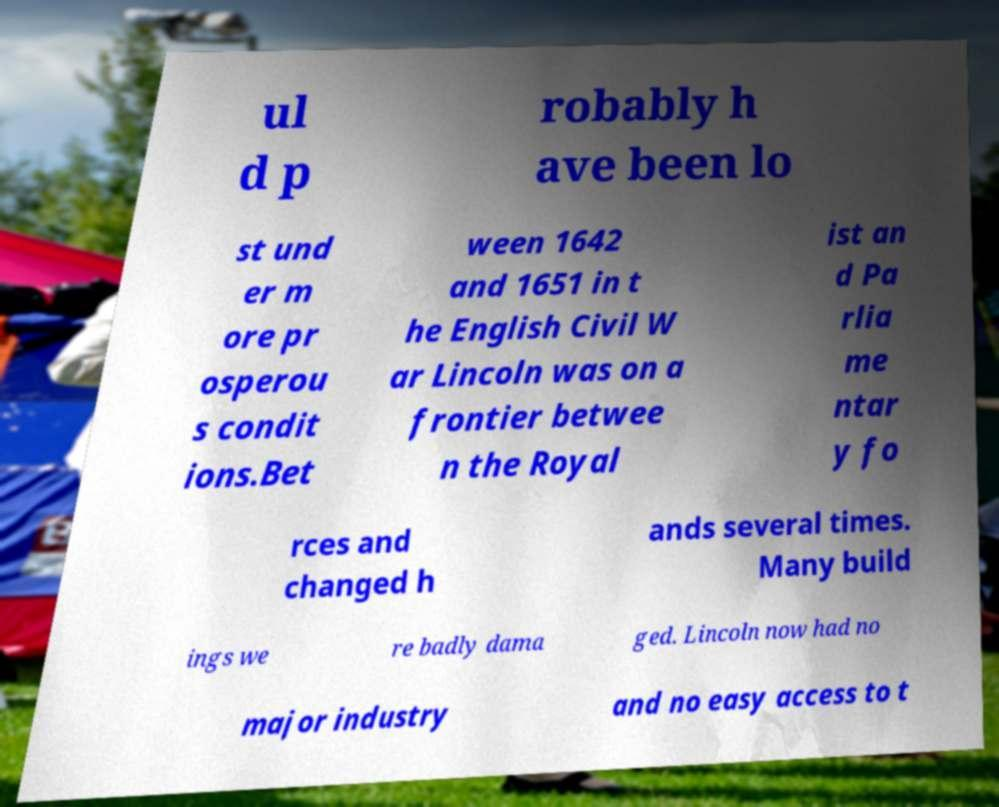Can you read and provide the text displayed in the image?This photo seems to have some interesting text. Can you extract and type it out for me? ul d p robably h ave been lo st und er m ore pr osperou s condit ions.Bet ween 1642 and 1651 in t he English Civil W ar Lincoln was on a frontier betwee n the Royal ist an d Pa rlia me ntar y fo rces and changed h ands several times. Many build ings we re badly dama ged. Lincoln now had no major industry and no easy access to t 